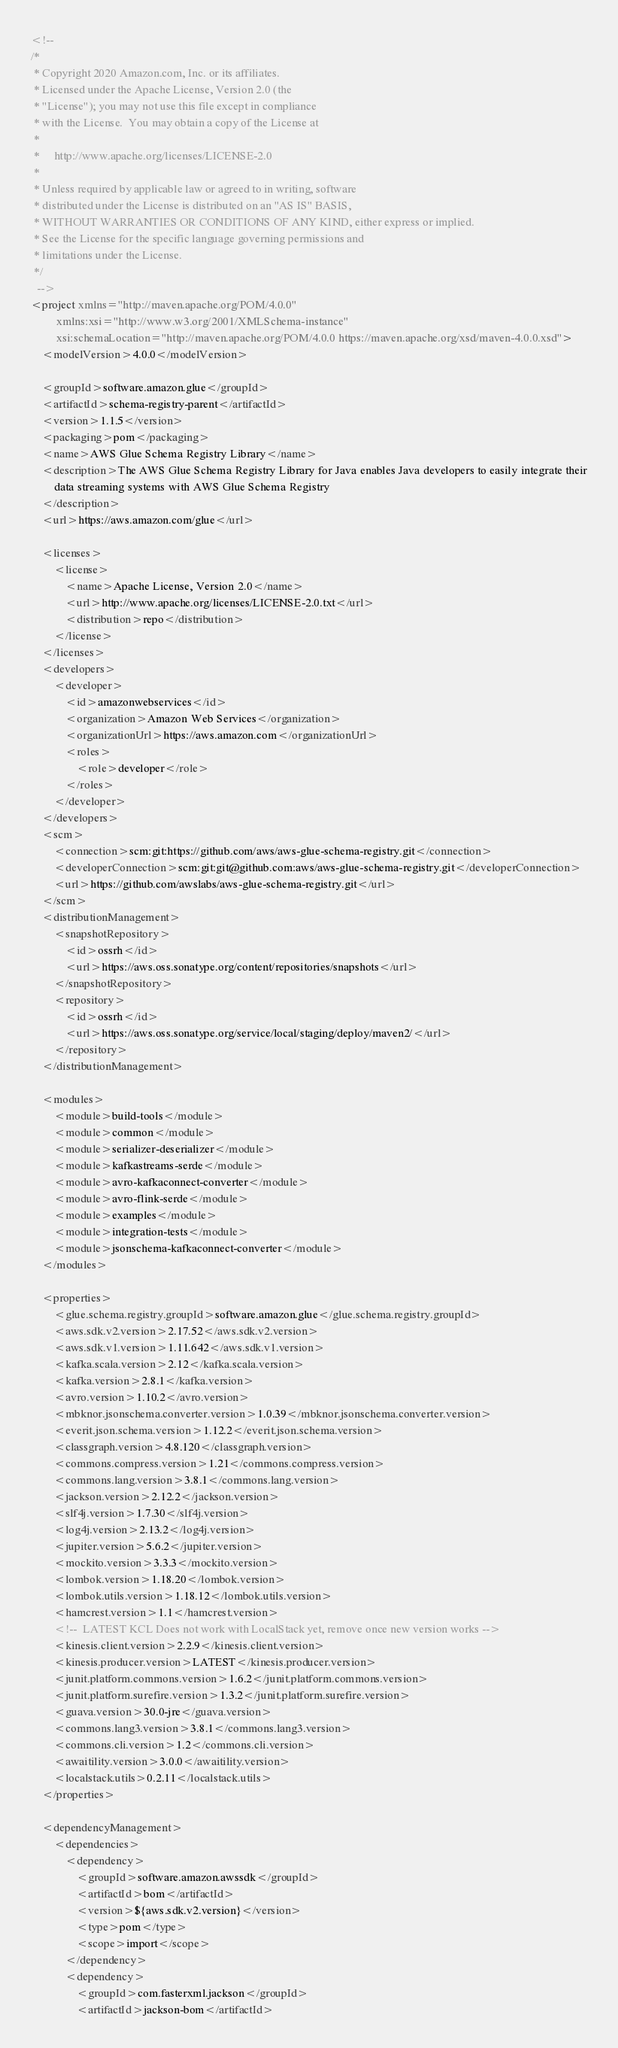Convert code to text. <code><loc_0><loc_0><loc_500><loc_500><_XML_><!--
/*
 * Copyright 2020 Amazon.com, Inc. or its affiliates.
 * Licensed under the Apache License, Version 2.0 (the
 * "License"); you may not use this file except in compliance
 * with the License.  You may obtain a copy of the License at
 *
 *     http://www.apache.org/licenses/LICENSE-2.0
 *
 * Unless required by applicable law or agreed to in writing, software
 * distributed under the License is distributed on an "AS IS" BASIS,
 * WITHOUT WARRANTIES OR CONDITIONS OF ANY KIND, either express or implied.
 * See the License for the specific language governing permissions and
 * limitations under the License.
 */
  -->
<project xmlns="http://maven.apache.org/POM/4.0.0"
         xmlns:xsi="http://www.w3.org/2001/XMLSchema-instance"
         xsi:schemaLocation="http://maven.apache.org/POM/4.0.0 https://maven.apache.org/xsd/maven-4.0.0.xsd">
    <modelVersion>4.0.0</modelVersion>

    <groupId>software.amazon.glue</groupId>
    <artifactId>schema-registry-parent</artifactId>
    <version>1.1.5</version>
    <packaging>pom</packaging>
    <name>AWS Glue Schema Registry Library</name>
    <description>The AWS Glue Schema Registry Library for Java enables Java developers to easily integrate their
        data streaming systems with AWS Glue Schema Registry
    </description>
    <url>https://aws.amazon.com/glue</url>

    <licenses>
        <license>
            <name>Apache License, Version 2.0</name>
            <url>http://www.apache.org/licenses/LICENSE-2.0.txt</url>
            <distribution>repo</distribution>
        </license>
    </licenses>
    <developers>
        <developer>
            <id>amazonwebservices</id>
            <organization>Amazon Web Services</organization>
            <organizationUrl>https://aws.amazon.com</organizationUrl>
            <roles>
                <role>developer</role>
            </roles>
        </developer>
    </developers>
    <scm>
        <connection>scm:git:https://github.com/aws/aws-glue-schema-registry.git</connection>
        <developerConnection>scm:git:git@github.com:aws/aws-glue-schema-registry.git</developerConnection>
        <url>https://github.com/awslabs/aws-glue-schema-registry.git</url>
    </scm>
    <distributionManagement>
        <snapshotRepository>
            <id>ossrh</id>
            <url>https://aws.oss.sonatype.org/content/repositories/snapshots</url>
        </snapshotRepository>
        <repository>
            <id>ossrh</id>
            <url>https://aws.oss.sonatype.org/service/local/staging/deploy/maven2/</url>
        </repository>
    </distributionManagement>

    <modules>
        <module>build-tools</module>
        <module>common</module>
        <module>serializer-deserializer</module>
        <module>kafkastreams-serde</module>
        <module>avro-kafkaconnect-converter</module>
        <module>avro-flink-serde</module>
        <module>examples</module>
        <module>integration-tests</module>
        <module>jsonschema-kafkaconnect-converter</module>
    </modules>

    <properties>
        <glue.schema.registry.groupId>software.amazon.glue</glue.schema.registry.groupId>
        <aws.sdk.v2.version>2.17.52</aws.sdk.v2.version>
        <aws.sdk.v1.version>1.11.642</aws.sdk.v1.version>
        <kafka.scala.version>2.12</kafka.scala.version>
        <kafka.version>2.8.1</kafka.version>
        <avro.version>1.10.2</avro.version>
        <mbknor.jsonschema.converter.version>1.0.39</mbknor.jsonschema.converter.version>
        <everit.json.schema.version>1.12.2</everit.json.schema.version>
        <classgraph.version>4.8.120</classgraph.version>
        <commons.compress.version>1.21</commons.compress.version>
        <commons.lang.version>3.8.1</commons.lang.version>
        <jackson.version>2.12.2</jackson.version>
        <slf4j.version>1.7.30</slf4j.version>
        <log4j.version>2.13.2</log4j.version>
        <jupiter.version>5.6.2</jupiter.version>
        <mockito.version>3.3.3</mockito.version>
        <lombok.version>1.18.20</lombok.version>
        <lombok.utils.version>1.18.12</lombok.utils.version>
        <hamcrest.version>1.1</hamcrest.version>
        <!--  LATEST KCL Does not work with LocalStack yet, remove once new version works -->
        <kinesis.client.version>2.2.9</kinesis.client.version>
        <kinesis.producer.version>LATEST</kinesis.producer.version>
        <junit.platform.commons.version>1.6.2</junit.platform.commons.version>
        <junit.platform.surefire.version>1.3.2</junit.platform.surefire.version>
        <guava.version>30.0-jre</guava.version>
        <commons.lang3.version>3.8.1</commons.lang3.version>
        <commons.cli.version>1.2</commons.cli.version>
        <awaitility.version>3.0.0</awaitility.version>
        <localstack.utils>0.2.11</localstack.utils>
    </properties>

    <dependencyManagement>
        <dependencies>
            <dependency>
                <groupId>software.amazon.awssdk</groupId>
                <artifactId>bom</artifactId>
                <version>${aws.sdk.v2.version}</version>
                <type>pom</type>
                <scope>import</scope>
            </dependency>
            <dependency>
                <groupId>com.fasterxml.jackson</groupId>
                <artifactId>jackson-bom</artifactId></code> 